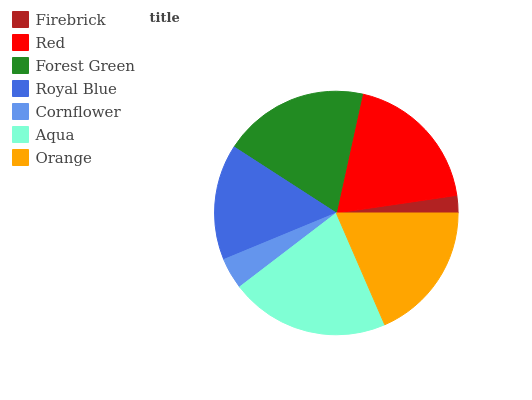Is Firebrick the minimum?
Answer yes or no. Yes. Is Aqua the maximum?
Answer yes or no. Yes. Is Red the minimum?
Answer yes or no. No. Is Red the maximum?
Answer yes or no. No. Is Red greater than Firebrick?
Answer yes or no. Yes. Is Firebrick less than Red?
Answer yes or no. Yes. Is Firebrick greater than Red?
Answer yes or no. No. Is Red less than Firebrick?
Answer yes or no. No. Is Orange the high median?
Answer yes or no. Yes. Is Orange the low median?
Answer yes or no. Yes. Is Royal Blue the high median?
Answer yes or no. No. Is Forest Green the low median?
Answer yes or no. No. 